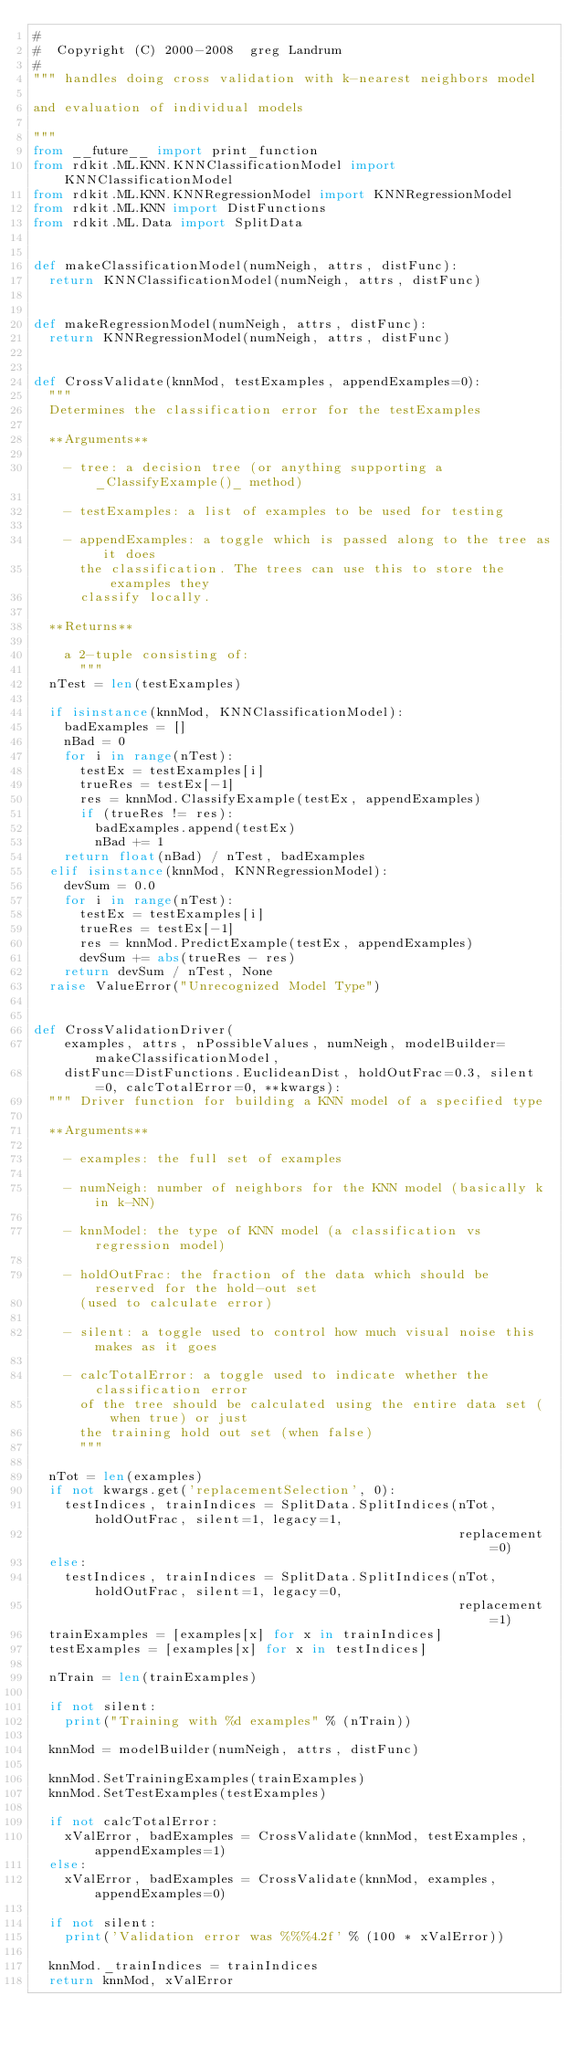<code> <loc_0><loc_0><loc_500><loc_500><_Python_>#
#  Copyright (C) 2000-2008  greg Landrum
#
""" handles doing cross validation with k-nearest neighbors model

and evaluation of individual models

"""
from __future__ import print_function
from rdkit.ML.KNN.KNNClassificationModel import KNNClassificationModel
from rdkit.ML.KNN.KNNRegressionModel import KNNRegressionModel
from rdkit.ML.KNN import DistFunctions
from rdkit.ML.Data import SplitData


def makeClassificationModel(numNeigh, attrs, distFunc):
  return KNNClassificationModel(numNeigh, attrs, distFunc)


def makeRegressionModel(numNeigh, attrs, distFunc):
  return KNNRegressionModel(numNeigh, attrs, distFunc)


def CrossValidate(knnMod, testExamples, appendExamples=0):
  """
  Determines the classification error for the testExamples

  **Arguments**

    - tree: a decision tree (or anything supporting a _ClassifyExample()_ method)

    - testExamples: a list of examples to be used for testing

    - appendExamples: a toggle which is passed along to the tree as it does
      the classification. The trees can use this to store the examples they
      classify locally.

  **Returns**

    a 2-tuple consisting of:
      """
  nTest = len(testExamples)

  if isinstance(knnMod, KNNClassificationModel):
    badExamples = []
    nBad = 0
    for i in range(nTest):
      testEx = testExamples[i]
      trueRes = testEx[-1]
      res = knnMod.ClassifyExample(testEx, appendExamples)
      if (trueRes != res):
        badExamples.append(testEx)
        nBad += 1
    return float(nBad) / nTest, badExamples
  elif isinstance(knnMod, KNNRegressionModel):
    devSum = 0.0
    for i in range(nTest):
      testEx = testExamples[i]
      trueRes = testEx[-1]
      res = knnMod.PredictExample(testEx, appendExamples)
      devSum += abs(trueRes - res)
    return devSum / nTest, None
  raise ValueError("Unrecognized Model Type")


def CrossValidationDriver(
    examples, attrs, nPossibleValues, numNeigh, modelBuilder=makeClassificationModel,
    distFunc=DistFunctions.EuclideanDist, holdOutFrac=0.3, silent=0, calcTotalError=0, **kwargs):
  """ Driver function for building a KNN model of a specified type

  **Arguments**

    - examples: the full set of examples

    - numNeigh: number of neighbors for the KNN model (basically k in k-NN)

    - knnModel: the type of KNN model (a classification vs regression model)

    - holdOutFrac: the fraction of the data which should be reserved for the hold-out set
      (used to calculate error)

    - silent: a toggle used to control how much visual noise this makes as it goes

    - calcTotalError: a toggle used to indicate whether the classification error
      of the tree should be calculated using the entire data set (when true) or just
      the training hold out set (when false)
      """

  nTot = len(examples)
  if not kwargs.get('replacementSelection', 0):
    testIndices, trainIndices = SplitData.SplitIndices(nTot, holdOutFrac, silent=1, legacy=1,
                                                       replacement=0)
  else:
    testIndices, trainIndices = SplitData.SplitIndices(nTot, holdOutFrac, silent=1, legacy=0,
                                                       replacement=1)
  trainExamples = [examples[x] for x in trainIndices]
  testExamples = [examples[x] for x in testIndices]

  nTrain = len(trainExamples)

  if not silent:
    print("Training with %d examples" % (nTrain))

  knnMod = modelBuilder(numNeigh, attrs, distFunc)

  knnMod.SetTrainingExamples(trainExamples)
  knnMod.SetTestExamples(testExamples)

  if not calcTotalError:
    xValError, badExamples = CrossValidate(knnMod, testExamples, appendExamples=1)
  else:
    xValError, badExamples = CrossValidate(knnMod, examples, appendExamples=0)

  if not silent:
    print('Validation error was %%%4.2f' % (100 * xValError))

  knnMod._trainIndices = trainIndices
  return knnMod, xValError
</code> 